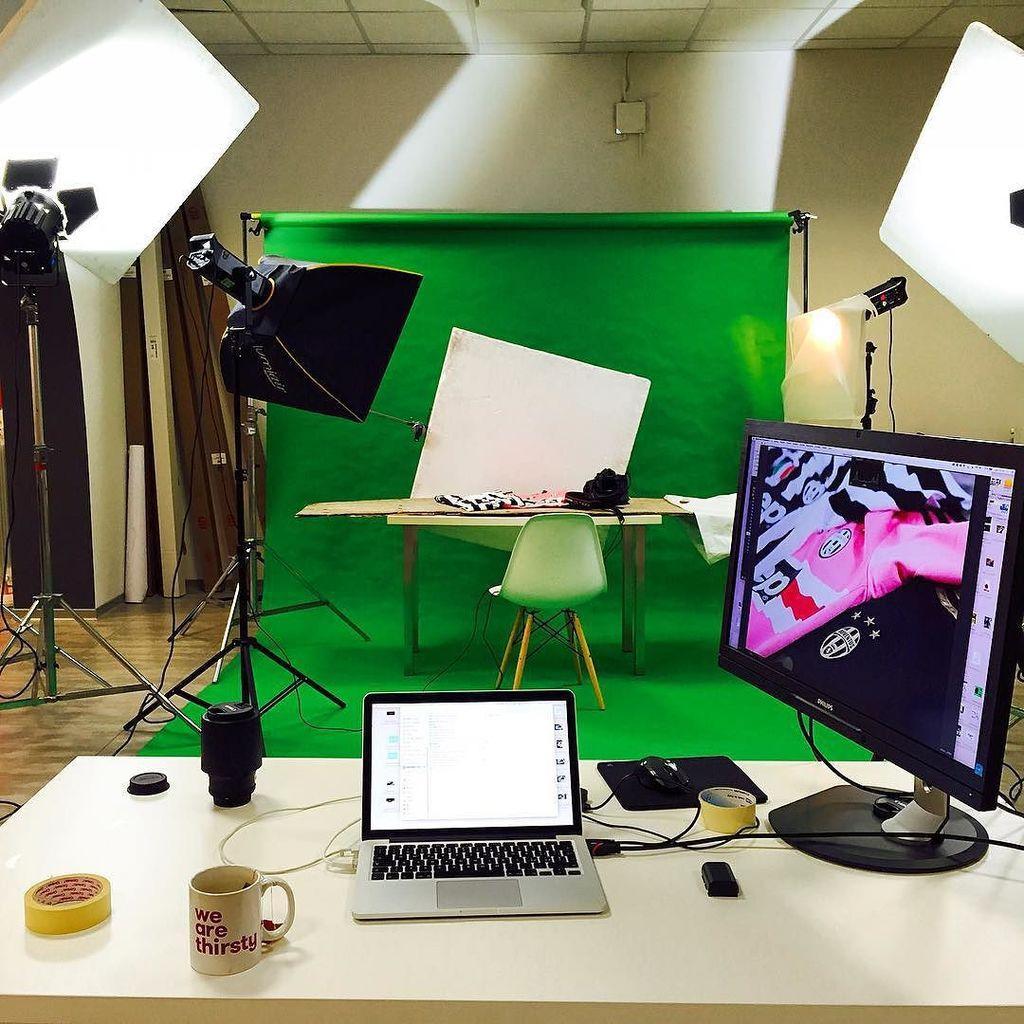Could you give a brief overview of what you see in this image? In the picture we can see a white table. On it we can see a monitor, one plaster, laptop, cup and a speaker with wires, in the background we can see a camera lights, table, chair a white board and a green curtain hanged to the wall , and a wall is white in color. 